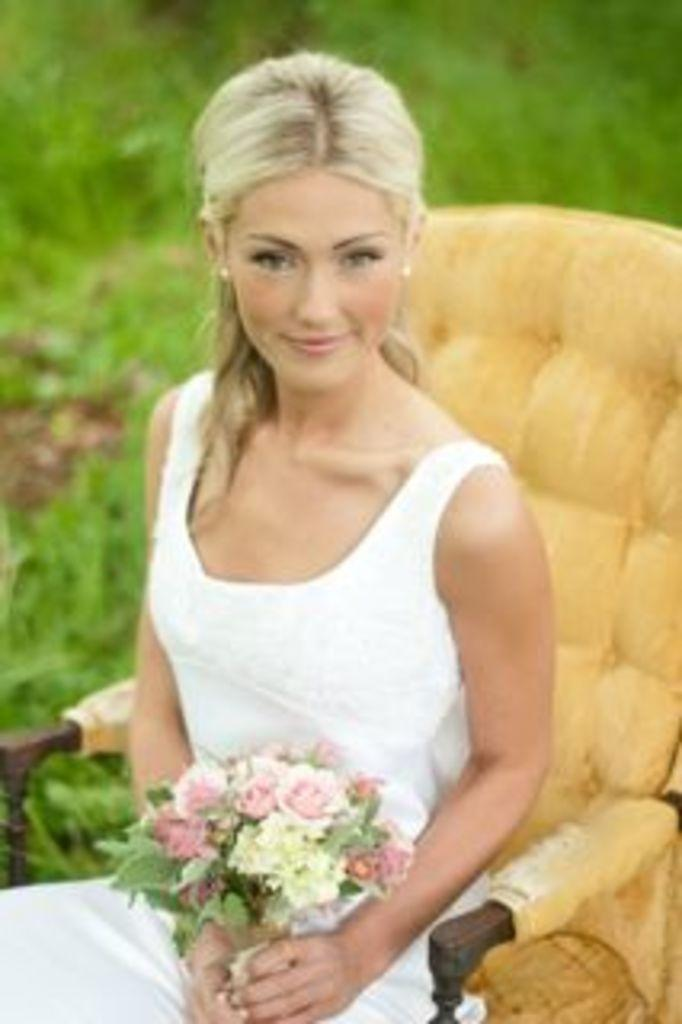Who is the main subject in the image? There is a girl in the image. What is the girl doing in the image? The girl is sitting on a chair. What is the girl holding in the image? The girl is holding a bouquet. What type of surface is visible behind the girl? There is grass on the ground behind the girl. What is the girl's opinion on folding halls in the image? There is no mention of opinions or folding halls in the image; it only shows a girl sitting on a chair and holding a bouquet. 